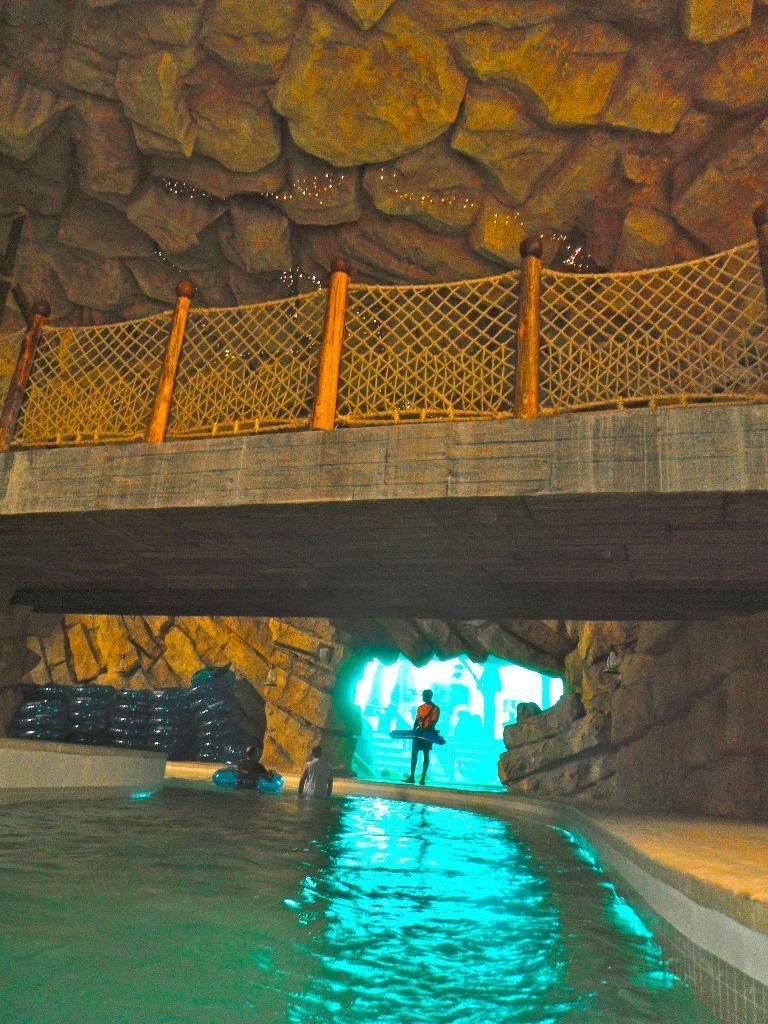Describe this image in one or two sentences. In the foreground of the picture there is water. In the center of the picture there are people and air balloons. At the top there is railing and stones. In the center of the background there are buildings. 